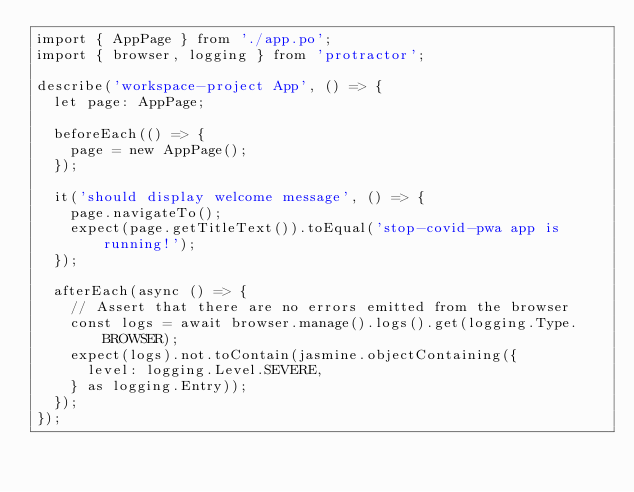Convert code to text. <code><loc_0><loc_0><loc_500><loc_500><_TypeScript_>import { AppPage } from './app.po';
import { browser, logging } from 'protractor';

describe('workspace-project App', () => {
  let page: AppPage;

  beforeEach(() => {
    page = new AppPage();
  });

  it('should display welcome message', () => {
    page.navigateTo();
    expect(page.getTitleText()).toEqual('stop-covid-pwa app is running!');
  });

  afterEach(async () => {
    // Assert that there are no errors emitted from the browser
    const logs = await browser.manage().logs().get(logging.Type.BROWSER);
    expect(logs).not.toContain(jasmine.objectContaining({
      level: logging.Level.SEVERE,
    } as logging.Entry));
  });
});
</code> 